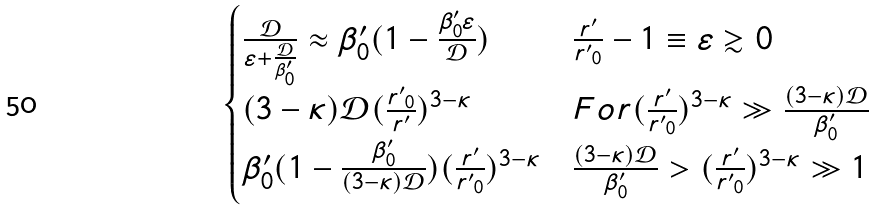Convert formula to latex. <formula><loc_0><loc_0><loc_500><loc_500>\begin{cases} \frac { \mathcal { D } } { \varepsilon + \frac { \mathcal { D } } { \beta ^ { \prime } _ { 0 } } } \approx \beta ^ { \prime } _ { 0 } ( 1 - \frac { \beta ^ { \prime } _ { 0 } \varepsilon } { \mathcal { D } } ) & \frac { r ^ { \prime } } { { r ^ { \prime } } _ { 0 } } - 1 \equiv \varepsilon \gtrsim 0 \\ ( 3 - \kappa ) { \mathcal { D } } ( \frac { { r ^ { \prime } } _ { 0 } } { r ^ { \prime } } ) ^ { 3 - \kappa } & F o r ( \frac { r ^ { \prime } } { { r ^ { \prime } } _ { 0 } } ) ^ { 3 - \kappa } \gg \frac { ( 3 - \kappa ) { \mathcal { D } } } { \beta ^ { \prime } _ { 0 } } \\ \beta ^ { \prime } _ { 0 } ( 1 - \frac { \beta ^ { \prime } _ { 0 } } { ( 3 - \kappa ) { \mathcal { D } } } ) ( \frac { r ^ { \prime } } { { r ^ { \prime } } _ { 0 } } ) ^ { 3 - \kappa } & \frac { ( 3 - \kappa ) { \mathcal { D } } } { \beta ^ { \prime } _ { 0 } } > ( \frac { r ^ { \prime } } { { r ^ { \prime } } _ { 0 } } ) ^ { 3 - \kappa } \gg 1 \end{cases}</formula> 